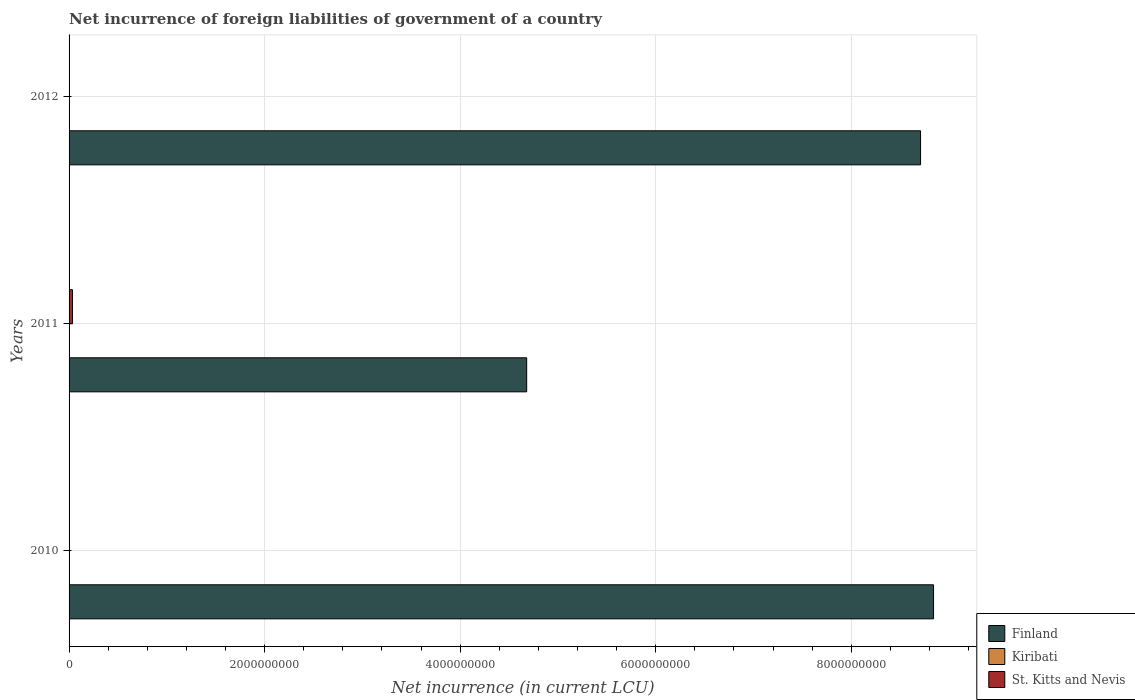How many different coloured bars are there?
Give a very brief answer. 3. Are the number of bars on each tick of the Y-axis equal?
Your response must be concise. No. How many bars are there on the 3rd tick from the top?
Ensure brevity in your answer.  2. How many bars are there on the 3rd tick from the bottom?
Your response must be concise. 3. In how many cases, is the number of bars for a given year not equal to the number of legend labels?
Provide a succinct answer. 1. What is the net incurrence of foreign liabilities in Finland in 2010?
Keep it short and to the point. 8.84e+09. Across all years, what is the maximum net incurrence of foreign liabilities in Kiribati?
Offer a very short reply. 3.50e+05. Across all years, what is the minimum net incurrence of foreign liabilities in Kiribati?
Offer a very short reply. 2.02e+05. In which year was the net incurrence of foreign liabilities in St. Kitts and Nevis maximum?
Provide a succinct answer. 2011. What is the total net incurrence of foreign liabilities in Finland in the graph?
Keep it short and to the point. 2.22e+1. What is the difference between the net incurrence of foreign liabilities in Kiribati in 2011 and that in 2012?
Your answer should be very brief. 1.02e+04. What is the difference between the net incurrence of foreign liabilities in St. Kitts and Nevis in 2010 and the net incurrence of foreign liabilities in Finland in 2011?
Keep it short and to the point. -4.68e+09. What is the average net incurrence of foreign liabilities in Kiribati per year?
Your answer should be compact. 2.97e+05. In the year 2010, what is the difference between the net incurrence of foreign liabilities in Kiribati and net incurrence of foreign liabilities in Finland?
Your response must be concise. -8.84e+09. What is the ratio of the net incurrence of foreign liabilities in Finland in 2011 to that in 2012?
Give a very brief answer. 0.54. Is the net incurrence of foreign liabilities in Finland in 2010 less than that in 2011?
Your response must be concise. No. Is the difference between the net incurrence of foreign liabilities in Kiribati in 2010 and 2011 greater than the difference between the net incurrence of foreign liabilities in Finland in 2010 and 2011?
Provide a succinct answer. No. What is the difference between the highest and the second highest net incurrence of foreign liabilities in Finland?
Make the answer very short. 1.33e+08. What is the difference between the highest and the lowest net incurrence of foreign liabilities in Finland?
Your response must be concise. 4.16e+09. Does the graph contain grids?
Offer a terse response. Yes. Where does the legend appear in the graph?
Your response must be concise. Bottom right. How many legend labels are there?
Offer a terse response. 3. How are the legend labels stacked?
Your response must be concise. Vertical. What is the title of the graph?
Your response must be concise. Net incurrence of foreign liabilities of government of a country. Does "Angola" appear as one of the legend labels in the graph?
Your answer should be very brief. No. What is the label or title of the X-axis?
Ensure brevity in your answer.  Net incurrence (in current LCU). What is the label or title of the Y-axis?
Provide a short and direct response. Years. What is the Net incurrence (in current LCU) of Finland in 2010?
Provide a succinct answer. 8.84e+09. What is the Net incurrence (in current LCU) in Kiribati in 2010?
Make the answer very short. 2.02e+05. What is the Net incurrence (in current LCU) of Finland in 2011?
Make the answer very short. 4.68e+09. What is the Net incurrence (in current LCU) in Kiribati in 2011?
Provide a succinct answer. 3.50e+05. What is the Net incurrence (in current LCU) in St. Kitts and Nevis in 2011?
Ensure brevity in your answer.  3.47e+07. What is the Net incurrence (in current LCU) of Finland in 2012?
Give a very brief answer. 8.71e+09. What is the Net incurrence (in current LCU) in Kiribati in 2012?
Ensure brevity in your answer.  3.40e+05. What is the Net incurrence (in current LCU) of St. Kitts and Nevis in 2012?
Give a very brief answer. 3.10e+06. Across all years, what is the maximum Net incurrence (in current LCU) of Finland?
Give a very brief answer. 8.84e+09. Across all years, what is the maximum Net incurrence (in current LCU) of Kiribati?
Offer a terse response. 3.50e+05. Across all years, what is the maximum Net incurrence (in current LCU) of St. Kitts and Nevis?
Provide a succinct answer. 3.47e+07. Across all years, what is the minimum Net incurrence (in current LCU) of Finland?
Give a very brief answer. 4.68e+09. Across all years, what is the minimum Net incurrence (in current LCU) in Kiribati?
Your answer should be compact. 2.02e+05. What is the total Net incurrence (in current LCU) of Finland in the graph?
Offer a very short reply. 2.22e+1. What is the total Net incurrence (in current LCU) in Kiribati in the graph?
Your response must be concise. 8.92e+05. What is the total Net incurrence (in current LCU) in St. Kitts and Nevis in the graph?
Offer a terse response. 3.78e+07. What is the difference between the Net incurrence (in current LCU) of Finland in 2010 and that in 2011?
Ensure brevity in your answer.  4.16e+09. What is the difference between the Net incurrence (in current LCU) in Kiribati in 2010 and that in 2011?
Give a very brief answer. -1.48e+05. What is the difference between the Net incurrence (in current LCU) in Finland in 2010 and that in 2012?
Provide a short and direct response. 1.33e+08. What is the difference between the Net incurrence (in current LCU) of Kiribati in 2010 and that in 2012?
Offer a very short reply. -1.37e+05. What is the difference between the Net incurrence (in current LCU) in Finland in 2011 and that in 2012?
Keep it short and to the point. -4.03e+09. What is the difference between the Net incurrence (in current LCU) of Kiribati in 2011 and that in 2012?
Your answer should be compact. 1.02e+04. What is the difference between the Net incurrence (in current LCU) in St. Kitts and Nevis in 2011 and that in 2012?
Give a very brief answer. 3.16e+07. What is the difference between the Net incurrence (in current LCU) in Finland in 2010 and the Net incurrence (in current LCU) in Kiribati in 2011?
Provide a short and direct response. 8.84e+09. What is the difference between the Net incurrence (in current LCU) in Finland in 2010 and the Net incurrence (in current LCU) in St. Kitts and Nevis in 2011?
Your answer should be compact. 8.81e+09. What is the difference between the Net incurrence (in current LCU) in Kiribati in 2010 and the Net incurrence (in current LCU) in St. Kitts and Nevis in 2011?
Make the answer very short. -3.45e+07. What is the difference between the Net incurrence (in current LCU) in Finland in 2010 and the Net incurrence (in current LCU) in Kiribati in 2012?
Offer a very short reply. 8.84e+09. What is the difference between the Net incurrence (in current LCU) of Finland in 2010 and the Net incurrence (in current LCU) of St. Kitts and Nevis in 2012?
Your response must be concise. 8.84e+09. What is the difference between the Net incurrence (in current LCU) of Kiribati in 2010 and the Net incurrence (in current LCU) of St. Kitts and Nevis in 2012?
Provide a succinct answer. -2.90e+06. What is the difference between the Net incurrence (in current LCU) of Finland in 2011 and the Net incurrence (in current LCU) of Kiribati in 2012?
Make the answer very short. 4.68e+09. What is the difference between the Net incurrence (in current LCU) in Finland in 2011 and the Net incurrence (in current LCU) in St. Kitts and Nevis in 2012?
Offer a very short reply. 4.68e+09. What is the difference between the Net incurrence (in current LCU) in Kiribati in 2011 and the Net incurrence (in current LCU) in St. Kitts and Nevis in 2012?
Give a very brief answer. -2.75e+06. What is the average Net incurrence (in current LCU) in Finland per year?
Keep it short and to the point. 7.41e+09. What is the average Net incurrence (in current LCU) in Kiribati per year?
Ensure brevity in your answer.  2.97e+05. What is the average Net incurrence (in current LCU) of St. Kitts and Nevis per year?
Provide a short and direct response. 1.26e+07. In the year 2010, what is the difference between the Net incurrence (in current LCU) in Finland and Net incurrence (in current LCU) in Kiribati?
Offer a terse response. 8.84e+09. In the year 2011, what is the difference between the Net incurrence (in current LCU) in Finland and Net incurrence (in current LCU) in Kiribati?
Offer a terse response. 4.68e+09. In the year 2011, what is the difference between the Net incurrence (in current LCU) in Finland and Net incurrence (in current LCU) in St. Kitts and Nevis?
Give a very brief answer. 4.65e+09. In the year 2011, what is the difference between the Net incurrence (in current LCU) in Kiribati and Net incurrence (in current LCU) in St. Kitts and Nevis?
Ensure brevity in your answer.  -3.43e+07. In the year 2012, what is the difference between the Net incurrence (in current LCU) of Finland and Net incurrence (in current LCU) of Kiribati?
Your response must be concise. 8.71e+09. In the year 2012, what is the difference between the Net incurrence (in current LCU) in Finland and Net incurrence (in current LCU) in St. Kitts and Nevis?
Ensure brevity in your answer.  8.70e+09. In the year 2012, what is the difference between the Net incurrence (in current LCU) in Kiribati and Net incurrence (in current LCU) in St. Kitts and Nevis?
Your answer should be compact. -2.76e+06. What is the ratio of the Net incurrence (in current LCU) of Finland in 2010 to that in 2011?
Keep it short and to the point. 1.89. What is the ratio of the Net incurrence (in current LCU) of Kiribati in 2010 to that in 2011?
Provide a short and direct response. 0.58. What is the ratio of the Net incurrence (in current LCU) in Finland in 2010 to that in 2012?
Offer a very short reply. 1.02. What is the ratio of the Net incurrence (in current LCU) in Kiribati in 2010 to that in 2012?
Keep it short and to the point. 0.6. What is the ratio of the Net incurrence (in current LCU) of Finland in 2011 to that in 2012?
Make the answer very short. 0.54. What is the ratio of the Net incurrence (in current LCU) of Kiribati in 2011 to that in 2012?
Offer a terse response. 1.03. What is the ratio of the Net incurrence (in current LCU) of St. Kitts and Nevis in 2011 to that in 2012?
Provide a succinct answer. 11.19. What is the difference between the highest and the second highest Net incurrence (in current LCU) of Finland?
Ensure brevity in your answer.  1.33e+08. What is the difference between the highest and the second highest Net incurrence (in current LCU) in Kiribati?
Your response must be concise. 1.02e+04. What is the difference between the highest and the lowest Net incurrence (in current LCU) in Finland?
Your response must be concise. 4.16e+09. What is the difference between the highest and the lowest Net incurrence (in current LCU) of Kiribati?
Ensure brevity in your answer.  1.48e+05. What is the difference between the highest and the lowest Net incurrence (in current LCU) in St. Kitts and Nevis?
Make the answer very short. 3.47e+07. 